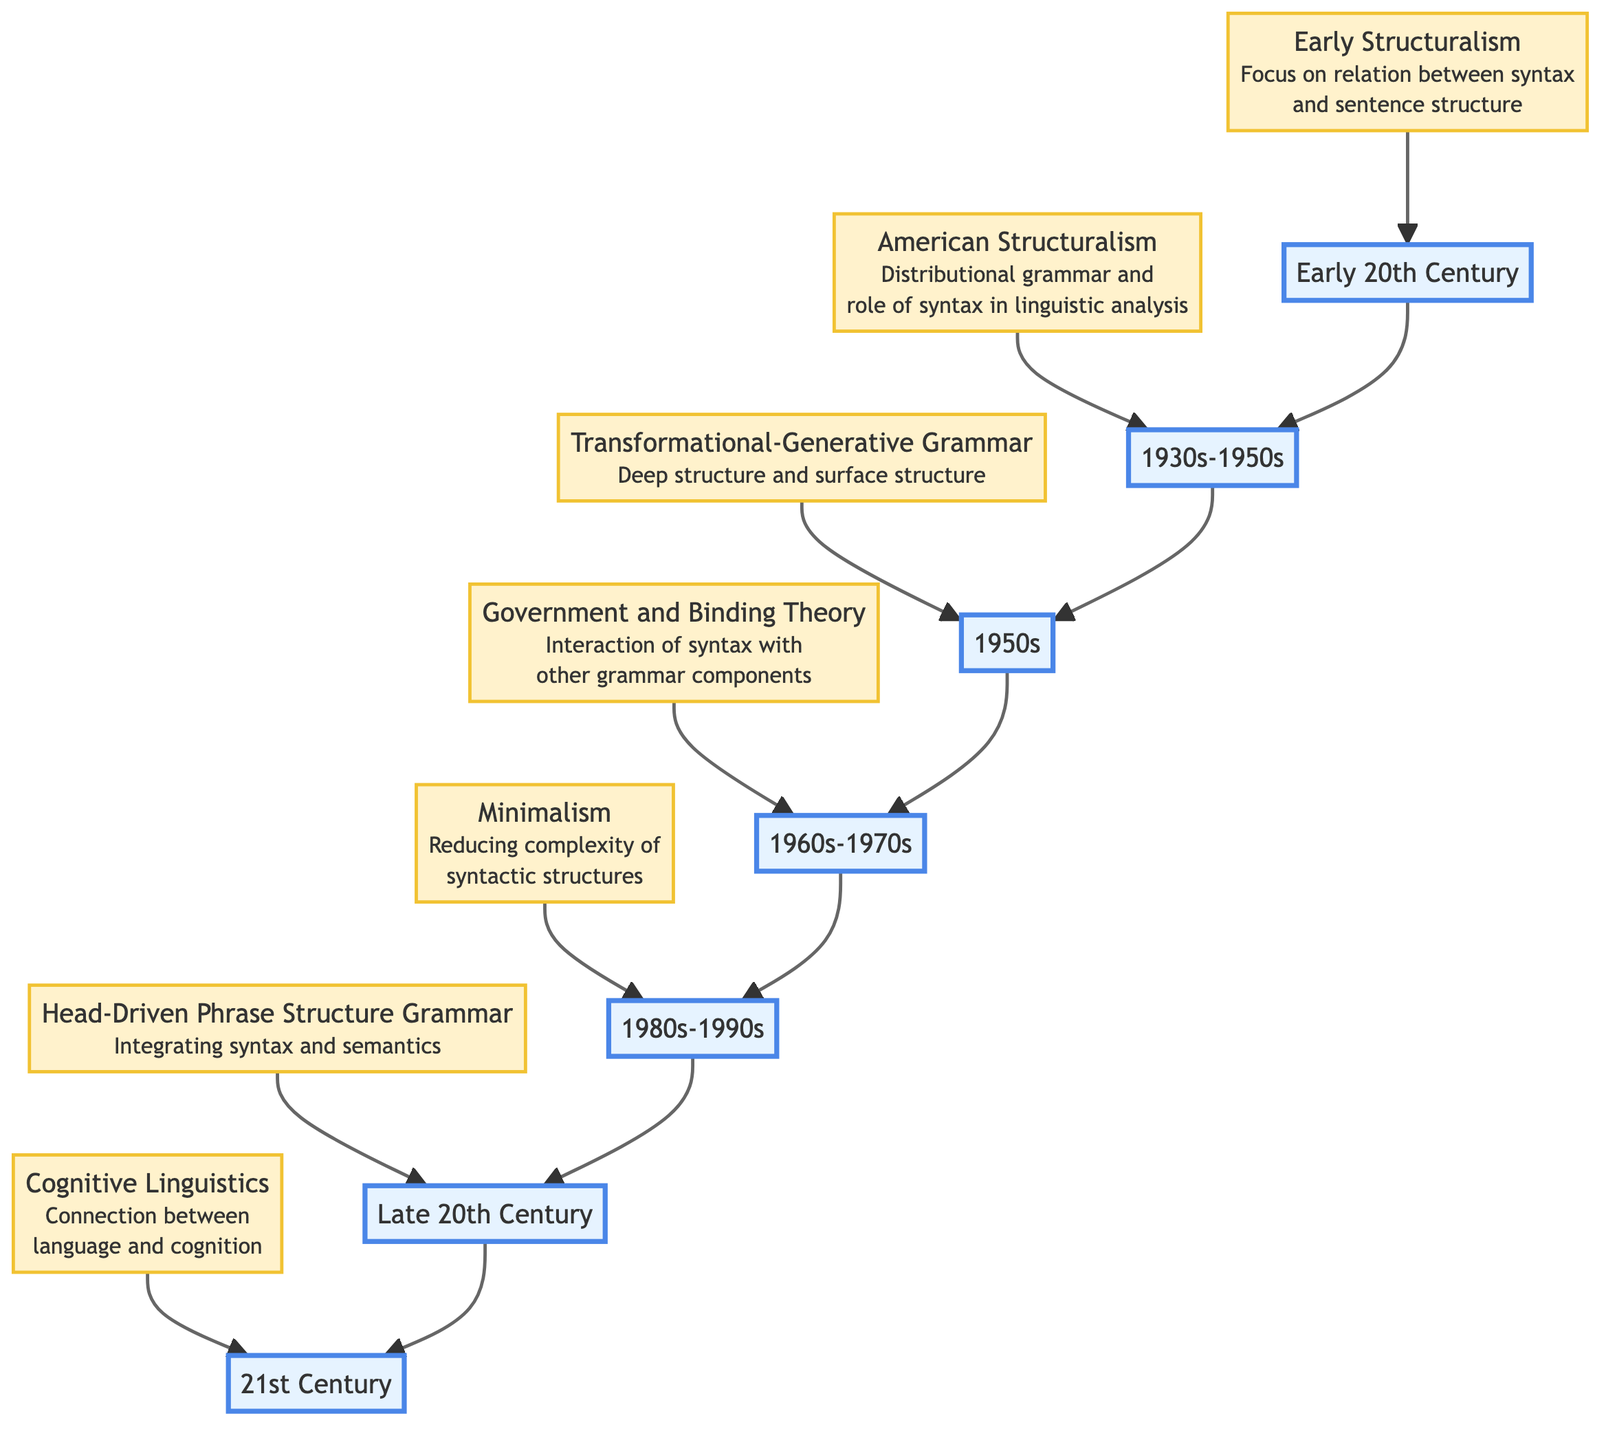What is the primary focus of Early Structuralism? Early Structuralism emphasizes the relationship between syntax and sentence structure, based on the theories of Ferdinand de Saussure. This information can be found directly under the node "Early Structuralism" in the diagram.
Answer: relation between syntax and sentence structure Which theoretical framework introduced the concepts of deep structure and surface structure? The concept of deep structure and surface structure was introduced by Noam Chomsky in the framework of Transformational-Generative Grammar. This can be traced from the node labeled "Transformational-Generative Grammar" in the diagram.
Answer: Transformational-Generative Grammar How many main theoretical frameworks are depicted in the diagram? The diagram depicts a total of seven different theoretical frameworks in syntax development as indicated by the number of nodes shown. By counting the distinct theoretical framework nodes, we arrive at this total.
Answer: seven During which time period was Minimalism developed? Minimalism was developed during the 1980s to 1990s, as indicated in the flow chart next to its corresponding theoretical framework node.
Answer: 1980s-1990s What relationship exists between American Structuralism and Transformational-Generative Grammar in the diagram? American Structuralism flows into Transformational-Generative Grammar, indicating that the developments in American Structuralism led to the advancement of Transformational-Generative Grammar. This is visible through the direct connection (arrow) between the two nodes.
Answer: sequential flow Who proposed Head-Driven Phrase Structure Grammar? Head-Driven Phrase Structure Grammar was proposed by Sag and others, as mentioned in the description of that theoretical framework node in the diagram.
Answer: Sag and others What is the overall trend in the development of syntactic theories from the early 20th century to the 21st century based on the diagram? The overall trend shows an evolution from Early Structuralism to the integration of cognitive aspects in 21st-century Cognitive Linguistics, suggesting a shift from structural to cognitive approaches in understanding syntax. This requires analyzing the flow of frameworks portrayed in the diagram.
Answer: evolution from structuralism to cognitive aspects What time period is associated with Government and Binding Theory? Government and Binding Theory is associated with the 1960s to 1970s, as shown next to this specific framework node in the diagram.
Answer: 1960s-1970s 